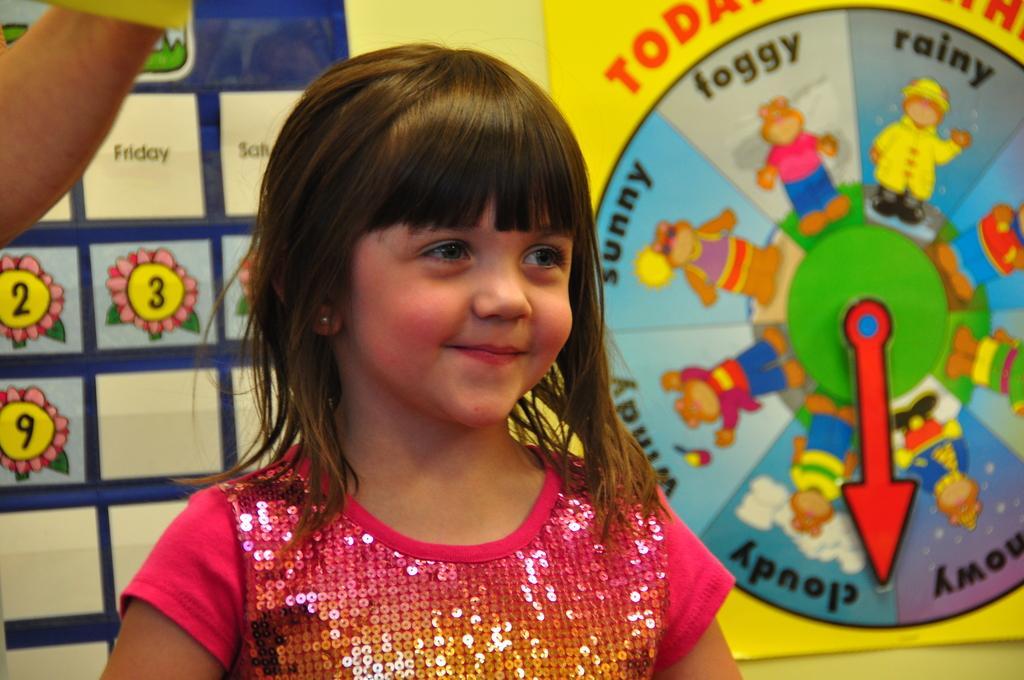In one or two sentences, can you explain what this image depicts? In this picture, we can see a small child, and we can see a person hand in the top left corner, and we can see the background with some posters on it. 